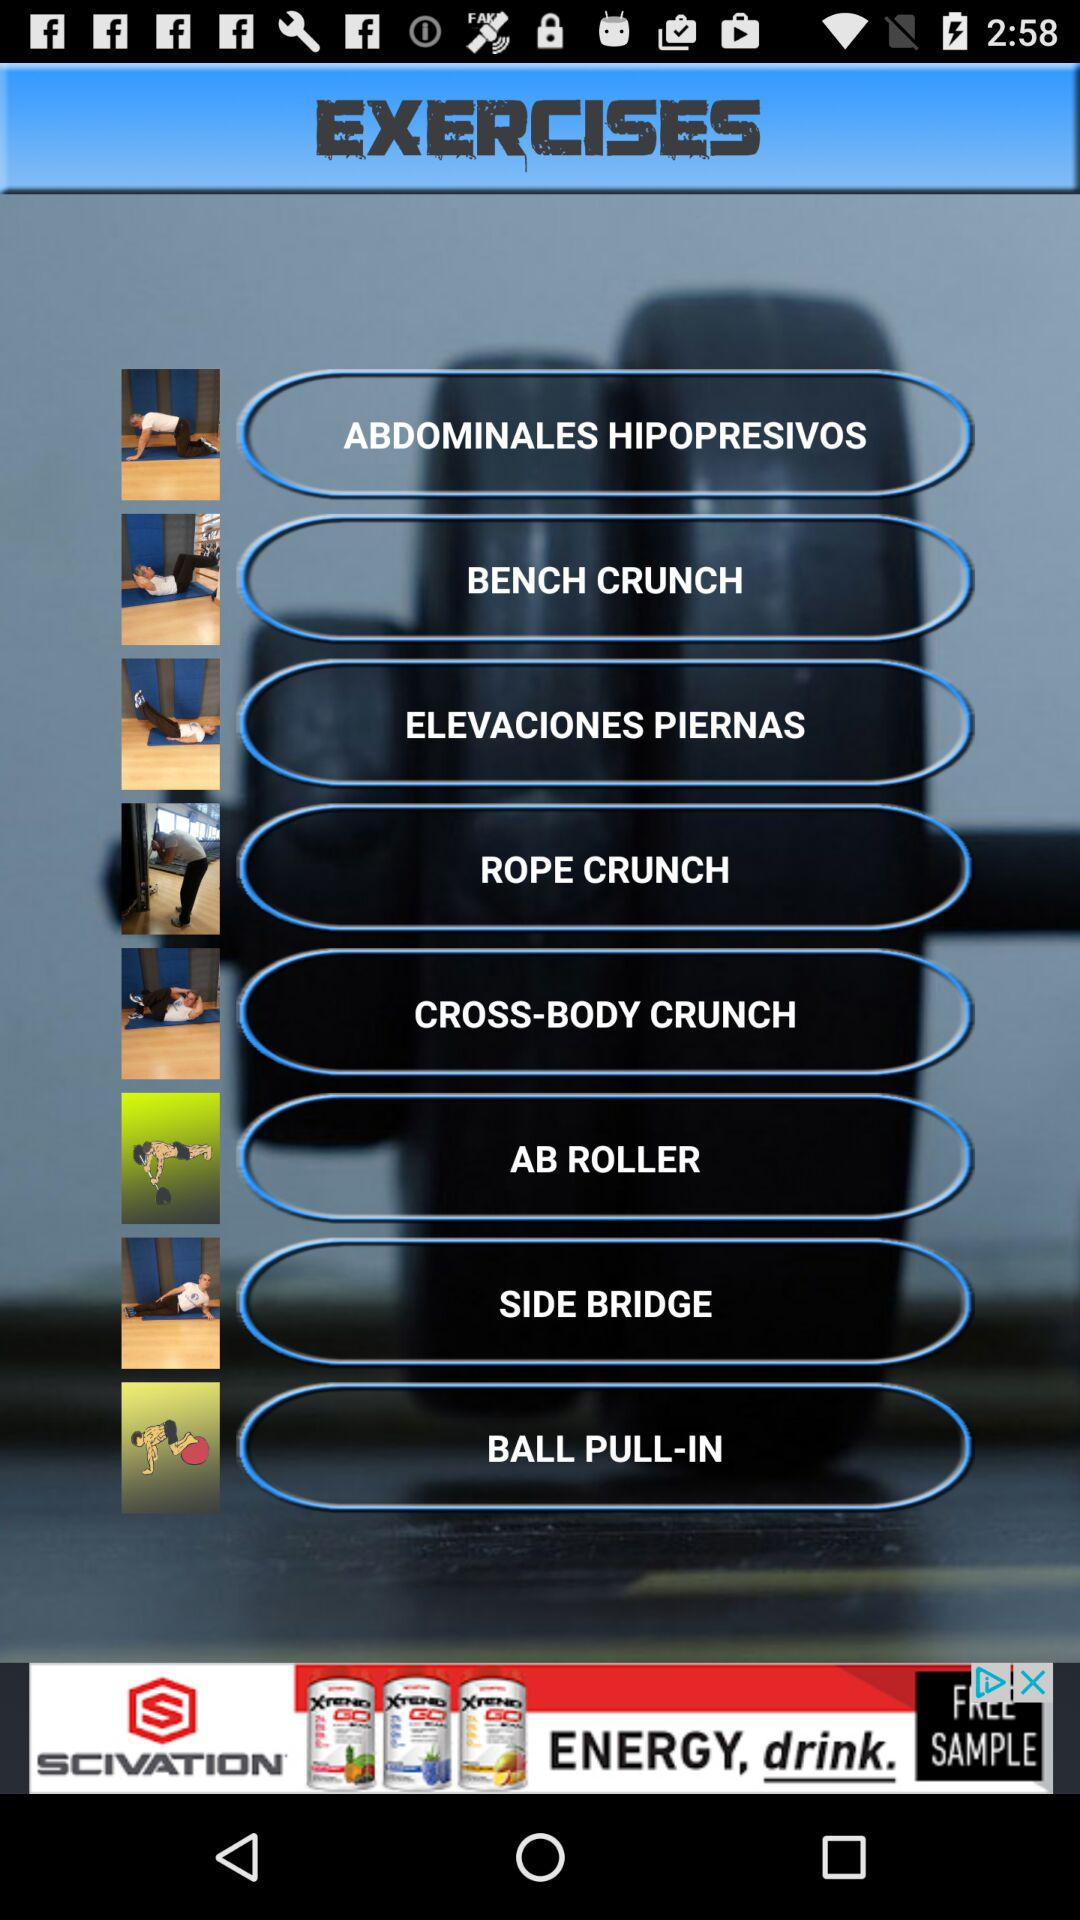How many calories does "AB ROLLER" burn?
When the provided information is insufficient, respond with <no answer>. <no answer> 